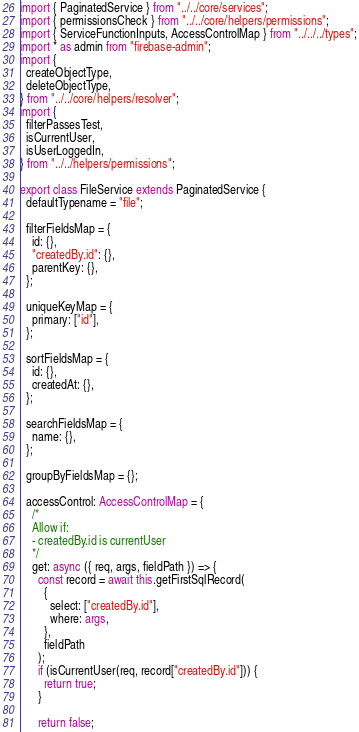Convert code to text. <code><loc_0><loc_0><loc_500><loc_500><_TypeScript_>import { PaginatedService } from "../../core/services";
import { permissionsCheck } from "../../core/helpers/permissions";
import { ServiceFunctionInputs, AccessControlMap } from "../../../types";
import * as admin from "firebase-admin";
import {
  createObjectType,
  deleteObjectType,
} from "../../core/helpers/resolver";
import {
  filterPassesTest,
  isCurrentUser,
  isUserLoggedIn,
} from "../../helpers/permissions";

export class FileService extends PaginatedService {
  defaultTypename = "file";

  filterFieldsMap = {
    id: {},
    "createdBy.id": {},
    parentKey: {},
  };

  uniqueKeyMap = {
    primary: ["id"],
  };

  sortFieldsMap = {
    id: {},
    createdAt: {},
  };

  searchFieldsMap = {
    name: {},
  };

  groupByFieldsMap = {};

  accessControl: AccessControlMap = {
    /*
    Allow if:
    - createdBy.id is currentUser
    */
    get: async ({ req, args, fieldPath }) => {
      const record = await this.getFirstSqlRecord(
        {
          select: ["createdBy.id"],
          where: args,
        },
        fieldPath
      );
      if (isCurrentUser(req, record["createdBy.id"])) {
        return true;
      }

      return false;</code> 